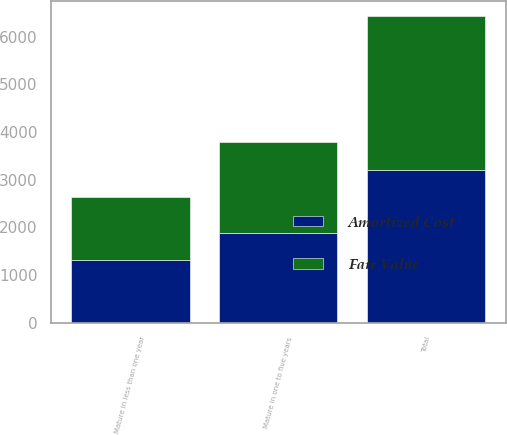Convert chart. <chart><loc_0><loc_0><loc_500><loc_500><stacked_bar_chart><ecel><fcel>Mature in less than one year<fcel>Mature in one to five years<fcel>Total<nl><fcel>Fair Value<fcel>1320.7<fcel>1898.3<fcel>3219<nl><fcel>Amortized Cost<fcel>1317.9<fcel>1885.9<fcel>3203.8<nl></chart> 